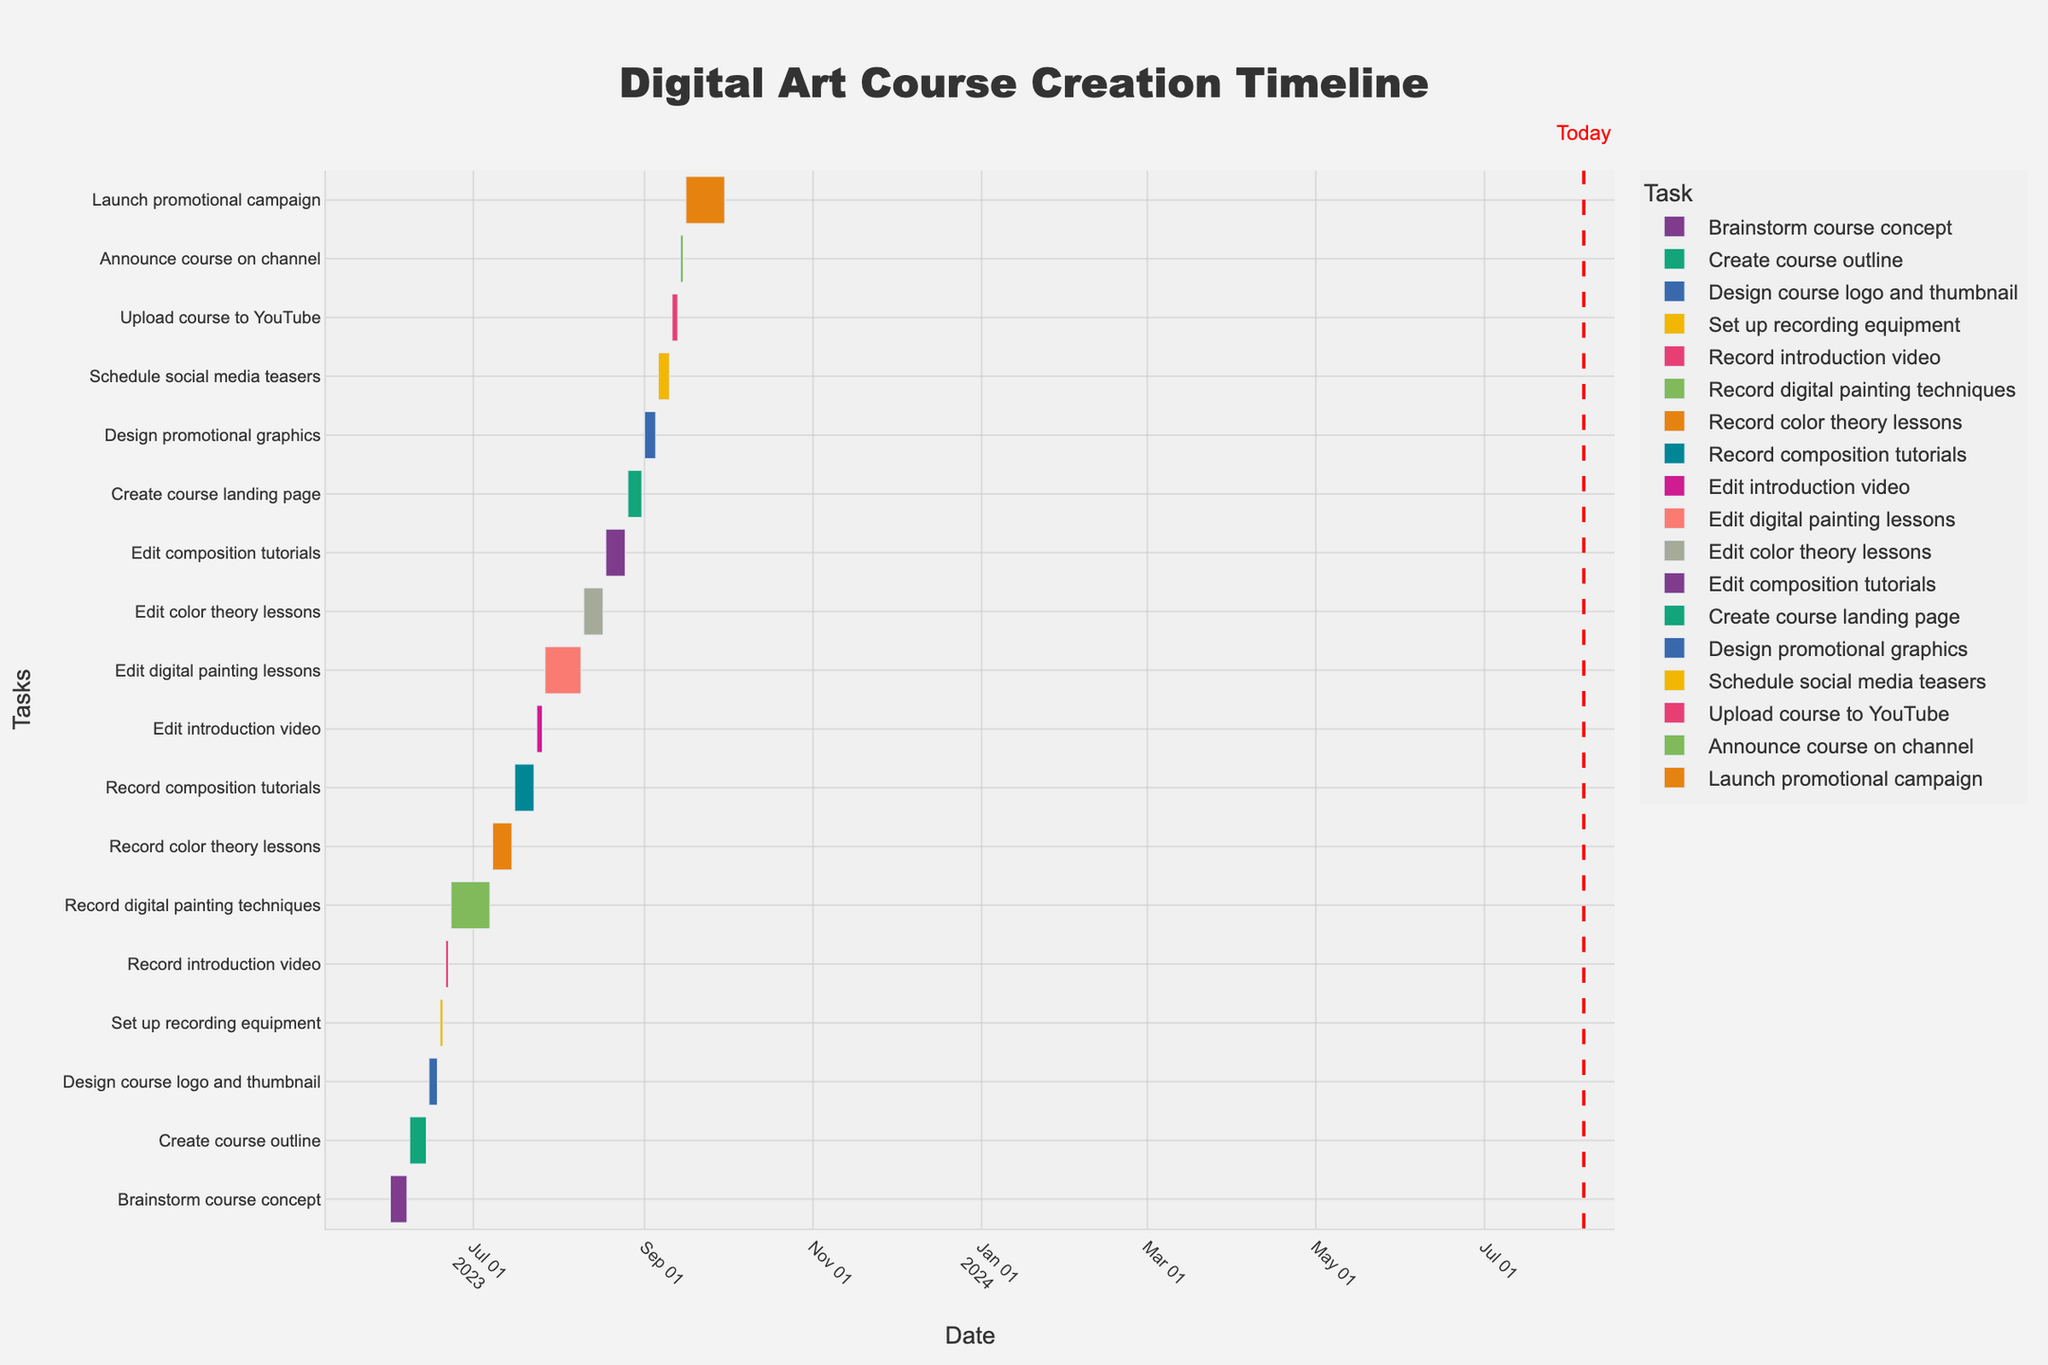What is the title of the chart? The title is typically displayed prominently at the top of the chart. By glancing at the top, we can see the chart’s identifier.
Answer: Digital Art Course Creation Timeline What are the start and end dates for the "Record digital painting techniques" task? Locate the "Record digital painting techniques" task on the y-axis and follow the associated bar to the x-axis to determine its start and end dates.
Answer: June 23, 2023, to July 7, 2023 Which task has the shortest duration and what are its start and end dates? By observing the lengths of the bars on the chart, the shortest bar corresponds to the shortest task. Cross-reference this bar with the y-axis to identify the task name and dates.
Answer: Set up recording equipment, June 19, 2023, to June 20, 2023 How long is the total duration from the start of "Brainstorm course concept" to the end of "Launch promotional campaign"? Identify the starting and ending tasks, then use the x-axis to find their respective dates. Calculate the difference between June 1, 2023, and September 30, 2023.
Answer: 122 days Which two tasks are scheduled consecutively without overlapping or breaks in between? Look for adjacent bars on the chart that align perfectly on the x-axis without any gap or overlap. Identify their names and start/end dates.
Answer: Set up recording equipment (ends June 20, 2023) and Record introduction video (starts June 21, 2023) Which task has the longest duration and what are its start and end dates? Compare the lengths of all the bars on the Gantt chart. The longest bar represents the longest duration task.
Answer: Record digital painting techniques, June 23, 2023, to July 7, 2023 How many tasks are scheduled to start in July? Count the number of bars on the chart that have their start date within the month of July.
Answer: 3 tasks (Record color theory lessons, Record composition tutorials, and Edit introduction video) What is the date marked as "Today" on the chart? Locate the vertical line labeled "Today" on the x-axis. This is the current date as indicated on the chart.
Answer: (Note: This date would be dynamically set, so verify based on the chart) During which period is the "Upload course to YouTube" task scheduled? Locate the "Upload course to YouTube" task on the y-axis and follow the associated bar to the x-axis to determine its duration.
Answer: September 11, 2023, to September 13, 2023 Which tasks fall within the month of August? Identify and list all the bars (tasks) that have any part of their duration falling within August by checking their start and end dates along the x-axis.
Answer: Edit digital painting lessons, Edit color theory lessons, Edit composition tutorials, Create course landing page 